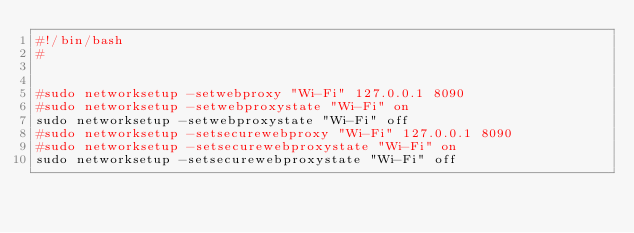Convert code to text. <code><loc_0><loc_0><loc_500><loc_500><_Bash_>#!/bin/bash
#


#sudo networksetup -setwebproxy "Wi-Fi" 127.0.0.1 8090
#sudo networksetup -setwebproxystate "Wi-Fi" on
sudo networksetup -setwebproxystate "Wi-Fi" off
#sudo networksetup -setsecurewebproxy "Wi-Fi" 127.0.0.1 8090
#sudo networksetup -setsecurewebproxystate "Wi-Fi" on
sudo networksetup -setsecurewebproxystate "Wi-Fi" off
</code> 